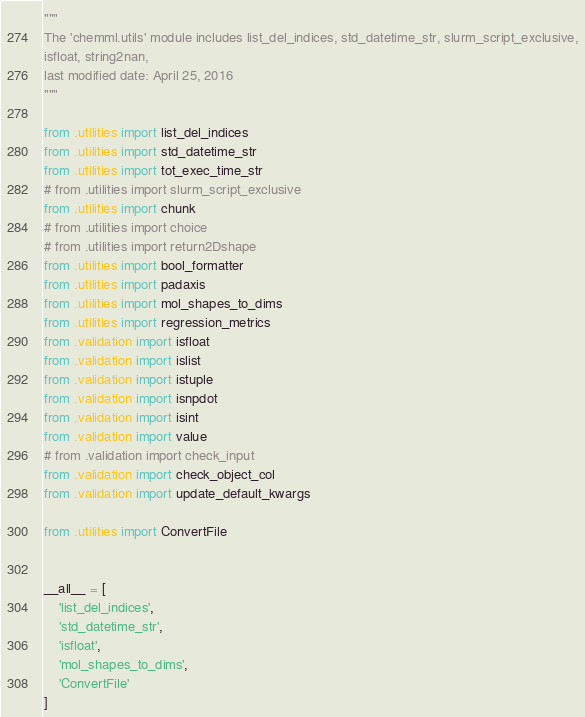<code> <loc_0><loc_0><loc_500><loc_500><_Python_>"""
The 'chemml.utils' module includes list_del_indices, std_datetime_str, slurm_script_exclusive,
isfloat, string2nan, 
last modified date: April 25, 2016
"""

from .utilities import list_del_indices
from .utilities import std_datetime_str
from .utilities import tot_exec_time_str
# from .utilities import slurm_script_exclusive
from .utilities import chunk
# from .utilities import choice
# from .utilities import return2Dshape
from .utilities import bool_formatter
from .utilities import padaxis
from .utilities import mol_shapes_to_dims
from .utilities import regression_metrics
from .validation import isfloat
from .validation import islist
from .validation import istuple
from .validation import isnpdot
from .validation import isint
from .validation import value
# from .validation import check_input
from .validation import check_object_col
from .validation import update_default_kwargs

from .utilities import ConvertFile


__all__ = [
    'list_del_indices',
    'std_datetime_str',
    'isfloat',
    'mol_shapes_to_dims',
    'ConvertFile'
]
</code> 